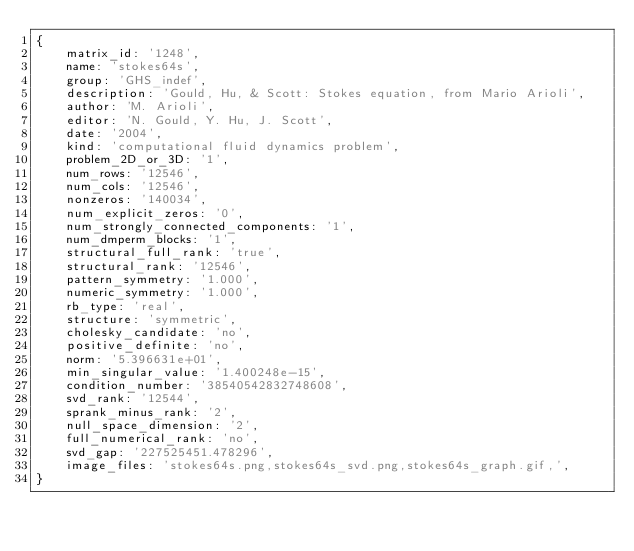<code> <loc_0><loc_0><loc_500><loc_500><_Ruby_>{
    matrix_id: '1248',
    name: 'stokes64s',
    group: 'GHS_indef',
    description: 'Gould, Hu, & Scott: Stokes equation, from Mario Arioli',
    author: 'M. Arioli',
    editor: 'N. Gould, Y. Hu, J. Scott',
    date: '2004',
    kind: 'computational fluid dynamics problem',
    problem_2D_or_3D: '1',
    num_rows: '12546',
    num_cols: '12546',
    nonzeros: '140034',
    num_explicit_zeros: '0',
    num_strongly_connected_components: '1',
    num_dmperm_blocks: '1',
    structural_full_rank: 'true',
    structural_rank: '12546',
    pattern_symmetry: '1.000',
    numeric_symmetry: '1.000',
    rb_type: 'real',
    structure: 'symmetric',
    cholesky_candidate: 'no',
    positive_definite: 'no',
    norm: '5.396631e+01',
    min_singular_value: '1.400248e-15',
    condition_number: '38540542832748608',
    svd_rank: '12544',
    sprank_minus_rank: '2',
    null_space_dimension: '2',
    full_numerical_rank: 'no',
    svd_gap: '227525451.478296',
    image_files: 'stokes64s.png,stokes64s_svd.png,stokes64s_graph.gif,',
}
</code> 